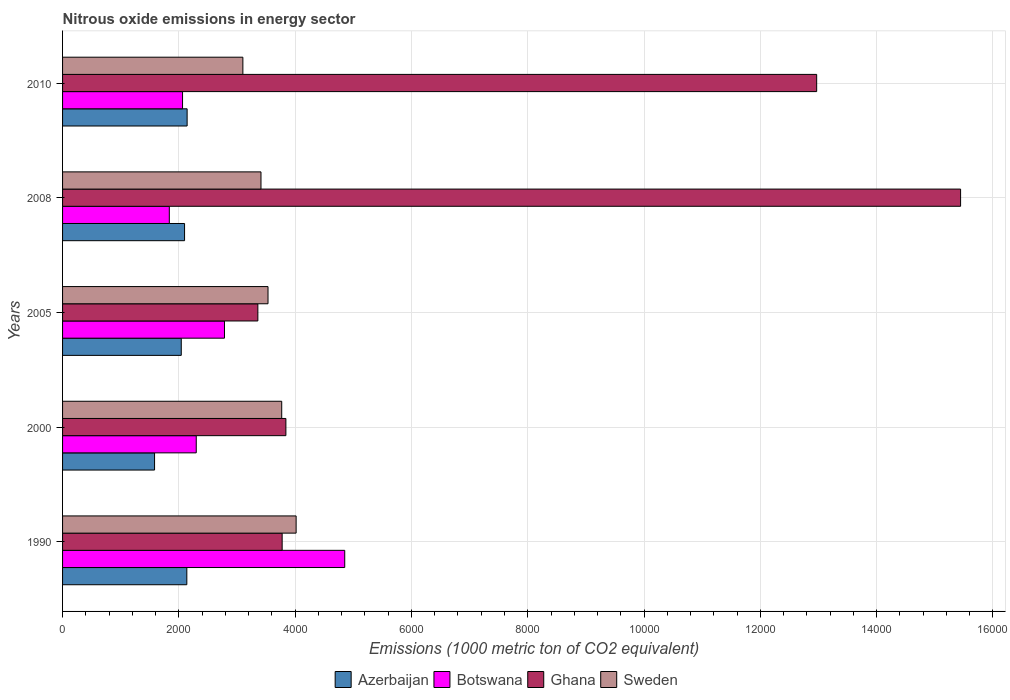How many different coloured bars are there?
Offer a very short reply. 4. Are the number of bars on each tick of the Y-axis equal?
Provide a short and direct response. Yes. How many bars are there on the 5th tick from the top?
Give a very brief answer. 4. How many bars are there on the 2nd tick from the bottom?
Your answer should be compact. 4. In how many cases, is the number of bars for a given year not equal to the number of legend labels?
Keep it short and to the point. 0. What is the amount of nitrous oxide emitted in Sweden in 2005?
Offer a terse response. 3533.4. Across all years, what is the maximum amount of nitrous oxide emitted in Ghana?
Keep it short and to the point. 1.54e+04. Across all years, what is the minimum amount of nitrous oxide emitted in Botswana?
Provide a succinct answer. 1835.8. In which year was the amount of nitrous oxide emitted in Azerbaijan maximum?
Provide a succinct answer. 2010. What is the total amount of nitrous oxide emitted in Azerbaijan in the graph?
Ensure brevity in your answer.  1.00e+04. What is the difference between the amount of nitrous oxide emitted in Ghana in 1990 and that in 2010?
Offer a very short reply. -9192.5. What is the difference between the amount of nitrous oxide emitted in Sweden in 1990 and the amount of nitrous oxide emitted in Botswana in 2008?
Your answer should be compact. 2180.9. What is the average amount of nitrous oxide emitted in Ghana per year?
Make the answer very short. 7877.78. In the year 1990, what is the difference between the amount of nitrous oxide emitted in Sweden and amount of nitrous oxide emitted in Azerbaijan?
Provide a short and direct response. 1879.6. What is the ratio of the amount of nitrous oxide emitted in Botswana in 2000 to that in 2008?
Provide a short and direct response. 1.25. What is the difference between the highest and the lowest amount of nitrous oxide emitted in Sweden?
Keep it short and to the point. 915.7. In how many years, is the amount of nitrous oxide emitted in Sweden greater than the average amount of nitrous oxide emitted in Sweden taken over all years?
Keep it short and to the point. 2. Is the sum of the amount of nitrous oxide emitted in Ghana in 1990 and 2005 greater than the maximum amount of nitrous oxide emitted in Botswana across all years?
Provide a succinct answer. Yes. Is it the case that in every year, the sum of the amount of nitrous oxide emitted in Azerbaijan and amount of nitrous oxide emitted in Botswana is greater than the sum of amount of nitrous oxide emitted in Sweden and amount of nitrous oxide emitted in Ghana?
Make the answer very short. Yes. What does the 1st bar from the top in 2000 represents?
Provide a short and direct response. Sweden. What does the 2nd bar from the bottom in 2005 represents?
Give a very brief answer. Botswana. Is it the case that in every year, the sum of the amount of nitrous oxide emitted in Ghana and amount of nitrous oxide emitted in Sweden is greater than the amount of nitrous oxide emitted in Azerbaijan?
Provide a succinct answer. Yes. How many bars are there?
Make the answer very short. 20. Are all the bars in the graph horizontal?
Offer a terse response. Yes. How many years are there in the graph?
Make the answer very short. 5. Are the values on the major ticks of X-axis written in scientific E-notation?
Offer a very short reply. No. Does the graph contain any zero values?
Provide a succinct answer. No. How are the legend labels stacked?
Offer a very short reply. Horizontal. What is the title of the graph?
Ensure brevity in your answer.  Nitrous oxide emissions in energy sector. What is the label or title of the X-axis?
Offer a very short reply. Emissions (1000 metric ton of CO2 equivalent). What is the Emissions (1000 metric ton of CO2 equivalent) of Azerbaijan in 1990?
Ensure brevity in your answer.  2137.1. What is the Emissions (1000 metric ton of CO2 equivalent) in Botswana in 1990?
Provide a short and direct response. 4852.7. What is the Emissions (1000 metric ton of CO2 equivalent) of Ghana in 1990?
Your answer should be compact. 3776.4. What is the Emissions (1000 metric ton of CO2 equivalent) of Sweden in 1990?
Your response must be concise. 4016.7. What is the Emissions (1000 metric ton of CO2 equivalent) of Azerbaijan in 2000?
Your answer should be compact. 1582.1. What is the Emissions (1000 metric ton of CO2 equivalent) of Botswana in 2000?
Provide a succinct answer. 2299. What is the Emissions (1000 metric ton of CO2 equivalent) of Ghana in 2000?
Keep it short and to the point. 3840.8. What is the Emissions (1000 metric ton of CO2 equivalent) of Sweden in 2000?
Keep it short and to the point. 3769. What is the Emissions (1000 metric ton of CO2 equivalent) in Azerbaijan in 2005?
Your response must be concise. 2041.5. What is the Emissions (1000 metric ton of CO2 equivalent) of Botswana in 2005?
Give a very brief answer. 2784.6. What is the Emissions (1000 metric ton of CO2 equivalent) in Ghana in 2005?
Keep it short and to the point. 3358.7. What is the Emissions (1000 metric ton of CO2 equivalent) of Sweden in 2005?
Ensure brevity in your answer.  3533.4. What is the Emissions (1000 metric ton of CO2 equivalent) in Azerbaijan in 2008?
Your response must be concise. 2098. What is the Emissions (1000 metric ton of CO2 equivalent) of Botswana in 2008?
Ensure brevity in your answer.  1835.8. What is the Emissions (1000 metric ton of CO2 equivalent) of Ghana in 2008?
Provide a succinct answer. 1.54e+04. What is the Emissions (1000 metric ton of CO2 equivalent) in Sweden in 2008?
Ensure brevity in your answer.  3412.4. What is the Emissions (1000 metric ton of CO2 equivalent) in Azerbaijan in 2010?
Your answer should be compact. 2142.1. What is the Emissions (1000 metric ton of CO2 equivalent) of Botswana in 2010?
Your answer should be very brief. 2063.5. What is the Emissions (1000 metric ton of CO2 equivalent) of Ghana in 2010?
Provide a short and direct response. 1.30e+04. What is the Emissions (1000 metric ton of CO2 equivalent) in Sweden in 2010?
Your response must be concise. 3101. Across all years, what is the maximum Emissions (1000 metric ton of CO2 equivalent) of Azerbaijan?
Make the answer very short. 2142.1. Across all years, what is the maximum Emissions (1000 metric ton of CO2 equivalent) in Botswana?
Your answer should be compact. 4852.7. Across all years, what is the maximum Emissions (1000 metric ton of CO2 equivalent) of Ghana?
Offer a very short reply. 1.54e+04. Across all years, what is the maximum Emissions (1000 metric ton of CO2 equivalent) in Sweden?
Keep it short and to the point. 4016.7. Across all years, what is the minimum Emissions (1000 metric ton of CO2 equivalent) of Azerbaijan?
Make the answer very short. 1582.1. Across all years, what is the minimum Emissions (1000 metric ton of CO2 equivalent) of Botswana?
Your response must be concise. 1835.8. Across all years, what is the minimum Emissions (1000 metric ton of CO2 equivalent) of Ghana?
Offer a very short reply. 3358.7. Across all years, what is the minimum Emissions (1000 metric ton of CO2 equivalent) in Sweden?
Offer a terse response. 3101. What is the total Emissions (1000 metric ton of CO2 equivalent) in Azerbaijan in the graph?
Your answer should be compact. 1.00e+04. What is the total Emissions (1000 metric ton of CO2 equivalent) of Botswana in the graph?
Provide a succinct answer. 1.38e+04. What is the total Emissions (1000 metric ton of CO2 equivalent) of Ghana in the graph?
Your answer should be very brief. 3.94e+04. What is the total Emissions (1000 metric ton of CO2 equivalent) in Sweden in the graph?
Provide a succinct answer. 1.78e+04. What is the difference between the Emissions (1000 metric ton of CO2 equivalent) in Azerbaijan in 1990 and that in 2000?
Make the answer very short. 555. What is the difference between the Emissions (1000 metric ton of CO2 equivalent) of Botswana in 1990 and that in 2000?
Provide a succinct answer. 2553.7. What is the difference between the Emissions (1000 metric ton of CO2 equivalent) of Ghana in 1990 and that in 2000?
Your answer should be compact. -64.4. What is the difference between the Emissions (1000 metric ton of CO2 equivalent) of Sweden in 1990 and that in 2000?
Provide a succinct answer. 247.7. What is the difference between the Emissions (1000 metric ton of CO2 equivalent) of Azerbaijan in 1990 and that in 2005?
Offer a terse response. 95.6. What is the difference between the Emissions (1000 metric ton of CO2 equivalent) in Botswana in 1990 and that in 2005?
Your response must be concise. 2068.1. What is the difference between the Emissions (1000 metric ton of CO2 equivalent) in Ghana in 1990 and that in 2005?
Keep it short and to the point. 417.7. What is the difference between the Emissions (1000 metric ton of CO2 equivalent) in Sweden in 1990 and that in 2005?
Offer a very short reply. 483.3. What is the difference between the Emissions (1000 metric ton of CO2 equivalent) of Azerbaijan in 1990 and that in 2008?
Your answer should be very brief. 39.1. What is the difference between the Emissions (1000 metric ton of CO2 equivalent) in Botswana in 1990 and that in 2008?
Your answer should be very brief. 3016.9. What is the difference between the Emissions (1000 metric ton of CO2 equivalent) of Ghana in 1990 and that in 2008?
Provide a succinct answer. -1.17e+04. What is the difference between the Emissions (1000 metric ton of CO2 equivalent) in Sweden in 1990 and that in 2008?
Your answer should be compact. 604.3. What is the difference between the Emissions (1000 metric ton of CO2 equivalent) of Azerbaijan in 1990 and that in 2010?
Ensure brevity in your answer.  -5. What is the difference between the Emissions (1000 metric ton of CO2 equivalent) of Botswana in 1990 and that in 2010?
Provide a succinct answer. 2789.2. What is the difference between the Emissions (1000 metric ton of CO2 equivalent) of Ghana in 1990 and that in 2010?
Provide a succinct answer. -9192.5. What is the difference between the Emissions (1000 metric ton of CO2 equivalent) of Sweden in 1990 and that in 2010?
Ensure brevity in your answer.  915.7. What is the difference between the Emissions (1000 metric ton of CO2 equivalent) in Azerbaijan in 2000 and that in 2005?
Ensure brevity in your answer.  -459.4. What is the difference between the Emissions (1000 metric ton of CO2 equivalent) in Botswana in 2000 and that in 2005?
Your answer should be compact. -485.6. What is the difference between the Emissions (1000 metric ton of CO2 equivalent) in Ghana in 2000 and that in 2005?
Offer a very short reply. 482.1. What is the difference between the Emissions (1000 metric ton of CO2 equivalent) in Sweden in 2000 and that in 2005?
Your answer should be compact. 235.6. What is the difference between the Emissions (1000 metric ton of CO2 equivalent) of Azerbaijan in 2000 and that in 2008?
Make the answer very short. -515.9. What is the difference between the Emissions (1000 metric ton of CO2 equivalent) of Botswana in 2000 and that in 2008?
Ensure brevity in your answer.  463.2. What is the difference between the Emissions (1000 metric ton of CO2 equivalent) in Ghana in 2000 and that in 2008?
Your answer should be very brief. -1.16e+04. What is the difference between the Emissions (1000 metric ton of CO2 equivalent) of Sweden in 2000 and that in 2008?
Give a very brief answer. 356.6. What is the difference between the Emissions (1000 metric ton of CO2 equivalent) in Azerbaijan in 2000 and that in 2010?
Offer a very short reply. -560. What is the difference between the Emissions (1000 metric ton of CO2 equivalent) in Botswana in 2000 and that in 2010?
Ensure brevity in your answer.  235.5. What is the difference between the Emissions (1000 metric ton of CO2 equivalent) in Ghana in 2000 and that in 2010?
Provide a succinct answer. -9128.1. What is the difference between the Emissions (1000 metric ton of CO2 equivalent) in Sweden in 2000 and that in 2010?
Your response must be concise. 668. What is the difference between the Emissions (1000 metric ton of CO2 equivalent) in Azerbaijan in 2005 and that in 2008?
Provide a short and direct response. -56.5. What is the difference between the Emissions (1000 metric ton of CO2 equivalent) of Botswana in 2005 and that in 2008?
Provide a succinct answer. 948.8. What is the difference between the Emissions (1000 metric ton of CO2 equivalent) of Ghana in 2005 and that in 2008?
Give a very brief answer. -1.21e+04. What is the difference between the Emissions (1000 metric ton of CO2 equivalent) in Sweden in 2005 and that in 2008?
Ensure brevity in your answer.  121. What is the difference between the Emissions (1000 metric ton of CO2 equivalent) in Azerbaijan in 2005 and that in 2010?
Your answer should be very brief. -100.6. What is the difference between the Emissions (1000 metric ton of CO2 equivalent) in Botswana in 2005 and that in 2010?
Offer a terse response. 721.1. What is the difference between the Emissions (1000 metric ton of CO2 equivalent) in Ghana in 2005 and that in 2010?
Provide a succinct answer. -9610.2. What is the difference between the Emissions (1000 metric ton of CO2 equivalent) of Sweden in 2005 and that in 2010?
Your response must be concise. 432.4. What is the difference between the Emissions (1000 metric ton of CO2 equivalent) in Azerbaijan in 2008 and that in 2010?
Keep it short and to the point. -44.1. What is the difference between the Emissions (1000 metric ton of CO2 equivalent) of Botswana in 2008 and that in 2010?
Your response must be concise. -227.7. What is the difference between the Emissions (1000 metric ton of CO2 equivalent) in Ghana in 2008 and that in 2010?
Give a very brief answer. 2475.2. What is the difference between the Emissions (1000 metric ton of CO2 equivalent) of Sweden in 2008 and that in 2010?
Make the answer very short. 311.4. What is the difference between the Emissions (1000 metric ton of CO2 equivalent) in Azerbaijan in 1990 and the Emissions (1000 metric ton of CO2 equivalent) in Botswana in 2000?
Your answer should be very brief. -161.9. What is the difference between the Emissions (1000 metric ton of CO2 equivalent) of Azerbaijan in 1990 and the Emissions (1000 metric ton of CO2 equivalent) of Ghana in 2000?
Your response must be concise. -1703.7. What is the difference between the Emissions (1000 metric ton of CO2 equivalent) of Azerbaijan in 1990 and the Emissions (1000 metric ton of CO2 equivalent) of Sweden in 2000?
Offer a very short reply. -1631.9. What is the difference between the Emissions (1000 metric ton of CO2 equivalent) in Botswana in 1990 and the Emissions (1000 metric ton of CO2 equivalent) in Ghana in 2000?
Your answer should be very brief. 1011.9. What is the difference between the Emissions (1000 metric ton of CO2 equivalent) of Botswana in 1990 and the Emissions (1000 metric ton of CO2 equivalent) of Sweden in 2000?
Give a very brief answer. 1083.7. What is the difference between the Emissions (1000 metric ton of CO2 equivalent) in Ghana in 1990 and the Emissions (1000 metric ton of CO2 equivalent) in Sweden in 2000?
Give a very brief answer. 7.4. What is the difference between the Emissions (1000 metric ton of CO2 equivalent) in Azerbaijan in 1990 and the Emissions (1000 metric ton of CO2 equivalent) in Botswana in 2005?
Offer a very short reply. -647.5. What is the difference between the Emissions (1000 metric ton of CO2 equivalent) in Azerbaijan in 1990 and the Emissions (1000 metric ton of CO2 equivalent) in Ghana in 2005?
Ensure brevity in your answer.  -1221.6. What is the difference between the Emissions (1000 metric ton of CO2 equivalent) in Azerbaijan in 1990 and the Emissions (1000 metric ton of CO2 equivalent) in Sweden in 2005?
Provide a succinct answer. -1396.3. What is the difference between the Emissions (1000 metric ton of CO2 equivalent) of Botswana in 1990 and the Emissions (1000 metric ton of CO2 equivalent) of Ghana in 2005?
Your response must be concise. 1494. What is the difference between the Emissions (1000 metric ton of CO2 equivalent) of Botswana in 1990 and the Emissions (1000 metric ton of CO2 equivalent) of Sweden in 2005?
Your answer should be compact. 1319.3. What is the difference between the Emissions (1000 metric ton of CO2 equivalent) of Ghana in 1990 and the Emissions (1000 metric ton of CO2 equivalent) of Sweden in 2005?
Offer a very short reply. 243. What is the difference between the Emissions (1000 metric ton of CO2 equivalent) in Azerbaijan in 1990 and the Emissions (1000 metric ton of CO2 equivalent) in Botswana in 2008?
Provide a succinct answer. 301.3. What is the difference between the Emissions (1000 metric ton of CO2 equivalent) in Azerbaijan in 1990 and the Emissions (1000 metric ton of CO2 equivalent) in Ghana in 2008?
Provide a succinct answer. -1.33e+04. What is the difference between the Emissions (1000 metric ton of CO2 equivalent) in Azerbaijan in 1990 and the Emissions (1000 metric ton of CO2 equivalent) in Sweden in 2008?
Provide a succinct answer. -1275.3. What is the difference between the Emissions (1000 metric ton of CO2 equivalent) of Botswana in 1990 and the Emissions (1000 metric ton of CO2 equivalent) of Ghana in 2008?
Your answer should be compact. -1.06e+04. What is the difference between the Emissions (1000 metric ton of CO2 equivalent) of Botswana in 1990 and the Emissions (1000 metric ton of CO2 equivalent) of Sweden in 2008?
Give a very brief answer. 1440.3. What is the difference between the Emissions (1000 metric ton of CO2 equivalent) in Ghana in 1990 and the Emissions (1000 metric ton of CO2 equivalent) in Sweden in 2008?
Your answer should be compact. 364. What is the difference between the Emissions (1000 metric ton of CO2 equivalent) in Azerbaijan in 1990 and the Emissions (1000 metric ton of CO2 equivalent) in Botswana in 2010?
Keep it short and to the point. 73.6. What is the difference between the Emissions (1000 metric ton of CO2 equivalent) of Azerbaijan in 1990 and the Emissions (1000 metric ton of CO2 equivalent) of Ghana in 2010?
Offer a terse response. -1.08e+04. What is the difference between the Emissions (1000 metric ton of CO2 equivalent) of Azerbaijan in 1990 and the Emissions (1000 metric ton of CO2 equivalent) of Sweden in 2010?
Offer a very short reply. -963.9. What is the difference between the Emissions (1000 metric ton of CO2 equivalent) in Botswana in 1990 and the Emissions (1000 metric ton of CO2 equivalent) in Ghana in 2010?
Provide a short and direct response. -8116.2. What is the difference between the Emissions (1000 metric ton of CO2 equivalent) of Botswana in 1990 and the Emissions (1000 metric ton of CO2 equivalent) of Sweden in 2010?
Make the answer very short. 1751.7. What is the difference between the Emissions (1000 metric ton of CO2 equivalent) in Ghana in 1990 and the Emissions (1000 metric ton of CO2 equivalent) in Sweden in 2010?
Your answer should be very brief. 675.4. What is the difference between the Emissions (1000 metric ton of CO2 equivalent) in Azerbaijan in 2000 and the Emissions (1000 metric ton of CO2 equivalent) in Botswana in 2005?
Make the answer very short. -1202.5. What is the difference between the Emissions (1000 metric ton of CO2 equivalent) in Azerbaijan in 2000 and the Emissions (1000 metric ton of CO2 equivalent) in Ghana in 2005?
Your response must be concise. -1776.6. What is the difference between the Emissions (1000 metric ton of CO2 equivalent) of Azerbaijan in 2000 and the Emissions (1000 metric ton of CO2 equivalent) of Sweden in 2005?
Your response must be concise. -1951.3. What is the difference between the Emissions (1000 metric ton of CO2 equivalent) in Botswana in 2000 and the Emissions (1000 metric ton of CO2 equivalent) in Ghana in 2005?
Provide a short and direct response. -1059.7. What is the difference between the Emissions (1000 metric ton of CO2 equivalent) in Botswana in 2000 and the Emissions (1000 metric ton of CO2 equivalent) in Sweden in 2005?
Provide a short and direct response. -1234.4. What is the difference between the Emissions (1000 metric ton of CO2 equivalent) in Ghana in 2000 and the Emissions (1000 metric ton of CO2 equivalent) in Sweden in 2005?
Give a very brief answer. 307.4. What is the difference between the Emissions (1000 metric ton of CO2 equivalent) in Azerbaijan in 2000 and the Emissions (1000 metric ton of CO2 equivalent) in Botswana in 2008?
Offer a terse response. -253.7. What is the difference between the Emissions (1000 metric ton of CO2 equivalent) of Azerbaijan in 2000 and the Emissions (1000 metric ton of CO2 equivalent) of Ghana in 2008?
Give a very brief answer. -1.39e+04. What is the difference between the Emissions (1000 metric ton of CO2 equivalent) in Azerbaijan in 2000 and the Emissions (1000 metric ton of CO2 equivalent) in Sweden in 2008?
Keep it short and to the point. -1830.3. What is the difference between the Emissions (1000 metric ton of CO2 equivalent) in Botswana in 2000 and the Emissions (1000 metric ton of CO2 equivalent) in Ghana in 2008?
Your response must be concise. -1.31e+04. What is the difference between the Emissions (1000 metric ton of CO2 equivalent) in Botswana in 2000 and the Emissions (1000 metric ton of CO2 equivalent) in Sweden in 2008?
Offer a very short reply. -1113.4. What is the difference between the Emissions (1000 metric ton of CO2 equivalent) in Ghana in 2000 and the Emissions (1000 metric ton of CO2 equivalent) in Sweden in 2008?
Make the answer very short. 428.4. What is the difference between the Emissions (1000 metric ton of CO2 equivalent) in Azerbaijan in 2000 and the Emissions (1000 metric ton of CO2 equivalent) in Botswana in 2010?
Your answer should be compact. -481.4. What is the difference between the Emissions (1000 metric ton of CO2 equivalent) in Azerbaijan in 2000 and the Emissions (1000 metric ton of CO2 equivalent) in Ghana in 2010?
Offer a terse response. -1.14e+04. What is the difference between the Emissions (1000 metric ton of CO2 equivalent) in Azerbaijan in 2000 and the Emissions (1000 metric ton of CO2 equivalent) in Sweden in 2010?
Ensure brevity in your answer.  -1518.9. What is the difference between the Emissions (1000 metric ton of CO2 equivalent) of Botswana in 2000 and the Emissions (1000 metric ton of CO2 equivalent) of Ghana in 2010?
Provide a succinct answer. -1.07e+04. What is the difference between the Emissions (1000 metric ton of CO2 equivalent) in Botswana in 2000 and the Emissions (1000 metric ton of CO2 equivalent) in Sweden in 2010?
Make the answer very short. -802. What is the difference between the Emissions (1000 metric ton of CO2 equivalent) in Ghana in 2000 and the Emissions (1000 metric ton of CO2 equivalent) in Sweden in 2010?
Offer a terse response. 739.8. What is the difference between the Emissions (1000 metric ton of CO2 equivalent) in Azerbaijan in 2005 and the Emissions (1000 metric ton of CO2 equivalent) in Botswana in 2008?
Give a very brief answer. 205.7. What is the difference between the Emissions (1000 metric ton of CO2 equivalent) of Azerbaijan in 2005 and the Emissions (1000 metric ton of CO2 equivalent) of Ghana in 2008?
Your response must be concise. -1.34e+04. What is the difference between the Emissions (1000 metric ton of CO2 equivalent) in Azerbaijan in 2005 and the Emissions (1000 metric ton of CO2 equivalent) in Sweden in 2008?
Provide a succinct answer. -1370.9. What is the difference between the Emissions (1000 metric ton of CO2 equivalent) of Botswana in 2005 and the Emissions (1000 metric ton of CO2 equivalent) of Ghana in 2008?
Give a very brief answer. -1.27e+04. What is the difference between the Emissions (1000 metric ton of CO2 equivalent) in Botswana in 2005 and the Emissions (1000 metric ton of CO2 equivalent) in Sweden in 2008?
Offer a terse response. -627.8. What is the difference between the Emissions (1000 metric ton of CO2 equivalent) in Ghana in 2005 and the Emissions (1000 metric ton of CO2 equivalent) in Sweden in 2008?
Give a very brief answer. -53.7. What is the difference between the Emissions (1000 metric ton of CO2 equivalent) in Azerbaijan in 2005 and the Emissions (1000 metric ton of CO2 equivalent) in Ghana in 2010?
Your response must be concise. -1.09e+04. What is the difference between the Emissions (1000 metric ton of CO2 equivalent) in Azerbaijan in 2005 and the Emissions (1000 metric ton of CO2 equivalent) in Sweden in 2010?
Your response must be concise. -1059.5. What is the difference between the Emissions (1000 metric ton of CO2 equivalent) in Botswana in 2005 and the Emissions (1000 metric ton of CO2 equivalent) in Ghana in 2010?
Make the answer very short. -1.02e+04. What is the difference between the Emissions (1000 metric ton of CO2 equivalent) of Botswana in 2005 and the Emissions (1000 metric ton of CO2 equivalent) of Sweden in 2010?
Offer a terse response. -316.4. What is the difference between the Emissions (1000 metric ton of CO2 equivalent) in Ghana in 2005 and the Emissions (1000 metric ton of CO2 equivalent) in Sweden in 2010?
Give a very brief answer. 257.7. What is the difference between the Emissions (1000 metric ton of CO2 equivalent) in Azerbaijan in 2008 and the Emissions (1000 metric ton of CO2 equivalent) in Botswana in 2010?
Keep it short and to the point. 34.5. What is the difference between the Emissions (1000 metric ton of CO2 equivalent) in Azerbaijan in 2008 and the Emissions (1000 metric ton of CO2 equivalent) in Ghana in 2010?
Give a very brief answer. -1.09e+04. What is the difference between the Emissions (1000 metric ton of CO2 equivalent) in Azerbaijan in 2008 and the Emissions (1000 metric ton of CO2 equivalent) in Sweden in 2010?
Your response must be concise. -1003. What is the difference between the Emissions (1000 metric ton of CO2 equivalent) of Botswana in 2008 and the Emissions (1000 metric ton of CO2 equivalent) of Ghana in 2010?
Ensure brevity in your answer.  -1.11e+04. What is the difference between the Emissions (1000 metric ton of CO2 equivalent) of Botswana in 2008 and the Emissions (1000 metric ton of CO2 equivalent) of Sweden in 2010?
Provide a short and direct response. -1265.2. What is the difference between the Emissions (1000 metric ton of CO2 equivalent) of Ghana in 2008 and the Emissions (1000 metric ton of CO2 equivalent) of Sweden in 2010?
Keep it short and to the point. 1.23e+04. What is the average Emissions (1000 metric ton of CO2 equivalent) in Azerbaijan per year?
Make the answer very short. 2000.16. What is the average Emissions (1000 metric ton of CO2 equivalent) in Botswana per year?
Your answer should be very brief. 2767.12. What is the average Emissions (1000 metric ton of CO2 equivalent) of Ghana per year?
Keep it short and to the point. 7877.78. What is the average Emissions (1000 metric ton of CO2 equivalent) of Sweden per year?
Provide a short and direct response. 3566.5. In the year 1990, what is the difference between the Emissions (1000 metric ton of CO2 equivalent) in Azerbaijan and Emissions (1000 metric ton of CO2 equivalent) in Botswana?
Offer a very short reply. -2715.6. In the year 1990, what is the difference between the Emissions (1000 metric ton of CO2 equivalent) of Azerbaijan and Emissions (1000 metric ton of CO2 equivalent) of Ghana?
Provide a succinct answer. -1639.3. In the year 1990, what is the difference between the Emissions (1000 metric ton of CO2 equivalent) of Azerbaijan and Emissions (1000 metric ton of CO2 equivalent) of Sweden?
Give a very brief answer. -1879.6. In the year 1990, what is the difference between the Emissions (1000 metric ton of CO2 equivalent) of Botswana and Emissions (1000 metric ton of CO2 equivalent) of Ghana?
Keep it short and to the point. 1076.3. In the year 1990, what is the difference between the Emissions (1000 metric ton of CO2 equivalent) of Botswana and Emissions (1000 metric ton of CO2 equivalent) of Sweden?
Offer a terse response. 836. In the year 1990, what is the difference between the Emissions (1000 metric ton of CO2 equivalent) of Ghana and Emissions (1000 metric ton of CO2 equivalent) of Sweden?
Your response must be concise. -240.3. In the year 2000, what is the difference between the Emissions (1000 metric ton of CO2 equivalent) in Azerbaijan and Emissions (1000 metric ton of CO2 equivalent) in Botswana?
Offer a terse response. -716.9. In the year 2000, what is the difference between the Emissions (1000 metric ton of CO2 equivalent) in Azerbaijan and Emissions (1000 metric ton of CO2 equivalent) in Ghana?
Keep it short and to the point. -2258.7. In the year 2000, what is the difference between the Emissions (1000 metric ton of CO2 equivalent) in Azerbaijan and Emissions (1000 metric ton of CO2 equivalent) in Sweden?
Your response must be concise. -2186.9. In the year 2000, what is the difference between the Emissions (1000 metric ton of CO2 equivalent) in Botswana and Emissions (1000 metric ton of CO2 equivalent) in Ghana?
Ensure brevity in your answer.  -1541.8. In the year 2000, what is the difference between the Emissions (1000 metric ton of CO2 equivalent) in Botswana and Emissions (1000 metric ton of CO2 equivalent) in Sweden?
Provide a succinct answer. -1470. In the year 2000, what is the difference between the Emissions (1000 metric ton of CO2 equivalent) in Ghana and Emissions (1000 metric ton of CO2 equivalent) in Sweden?
Your answer should be very brief. 71.8. In the year 2005, what is the difference between the Emissions (1000 metric ton of CO2 equivalent) in Azerbaijan and Emissions (1000 metric ton of CO2 equivalent) in Botswana?
Make the answer very short. -743.1. In the year 2005, what is the difference between the Emissions (1000 metric ton of CO2 equivalent) in Azerbaijan and Emissions (1000 metric ton of CO2 equivalent) in Ghana?
Ensure brevity in your answer.  -1317.2. In the year 2005, what is the difference between the Emissions (1000 metric ton of CO2 equivalent) in Azerbaijan and Emissions (1000 metric ton of CO2 equivalent) in Sweden?
Your answer should be compact. -1491.9. In the year 2005, what is the difference between the Emissions (1000 metric ton of CO2 equivalent) of Botswana and Emissions (1000 metric ton of CO2 equivalent) of Ghana?
Your answer should be very brief. -574.1. In the year 2005, what is the difference between the Emissions (1000 metric ton of CO2 equivalent) in Botswana and Emissions (1000 metric ton of CO2 equivalent) in Sweden?
Offer a terse response. -748.8. In the year 2005, what is the difference between the Emissions (1000 metric ton of CO2 equivalent) of Ghana and Emissions (1000 metric ton of CO2 equivalent) of Sweden?
Make the answer very short. -174.7. In the year 2008, what is the difference between the Emissions (1000 metric ton of CO2 equivalent) in Azerbaijan and Emissions (1000 metric ton of CO2 equivalent) in Botswana?
Offer a terse response. 262.2. In the year 2008, what is the difference between the Emissions (1000 metric ton of CO2 equivalent) of Azerbaijan and Emissions (1000 metric ton of CO2 equivalent) of Ghana?
Ensure brevity in your answer.  -1.33e+04. In the year 2008, what is the difference between the Emissions (1000 metric ton of CO2 equivalent) of Azerbaijan and Emissions (1000 metric ton of CO2 equivalent) of Sweden?
Make the answer very short. -1314.4. In the year 2008, what is the difference between the Emissions (1000 metric ton of CO2 equivalent) in Botswana and Emissions (1000 metric ton of CO2 equivalent) in Ghana?
Ensure brevity in your answer.  -1.36e+04. In the year 2008, what is the difference between the Emissions (1000 metric ton of CO2 equivalent) of Botswana and Emissions (1000 metric ton of CO2 equivalent) of Sweden?
Keep it short and to the point. -1576.6. In the year 2008, what is the difference between the Emissions (1000 metric ton of CO2 equivalent) of Ghana and Emissions (1000 metric ton of CO2 equivalent) of Sweden?
Provide a short and direct response. 1.20e+04. In the year 2010, what is the difference between the Emissions (1000 metric ton of CO2 equivalent) in Azerbaijan and Emissions (1000 metric ton of CO2 equivalent) in Botswana?
Keep it short and to the point. 78.6. In the year 2010, what is the difference between the Emissions (1000 metric ton of CO2 equivalent) in Azerbaijan and Emissions (1000 metric ton of CO2 equivalent) in Ghana?
Make the answer very short. -1.08e+04. In the year 2010, what is the difference between the Emissions (1000 metric ton of CO2 equivalent) in Azerbaijan and Emissions (1000 metric ton of CO2 equivalent) in Sweden?
Give a very brief answer. -958.9. In the year 2010, what is the difference between the Emissions (1000 metric ton of CO2 equivalent) in Botswana and Emissions (1000 metric ton of CO2 equivalent) in Ghana?
Your response must be concise. -1.09e+04. In the year 2010, what is the difference between the Emissions (1000 metric ton of CO2 equivalent) of Botswana and Emissions (1000 metric ton of CO2 equivalent) of Sweden?
Offer a terse response. -1037.5. In the year 2010, what is the difference between the Emissions (1000 metric ton of CO2 equivalent) of Ghana and Emissions (1000 metric ton of CO2 equivalent) of Sweden?
Offer a very short reply. 9867.9. What is the ratio of the Emissions (1000 metric ton of CO2 equivalent) of Azerbaijan in 1990 to that in 2000?
Provide a succinct answer. 1.35. What is the ratio of the Emissions (1000 metric ton of CO2 equivalent) in Botswana in 1990 to that in 2000?
Keep it short and to the point. 2.11. What is the ratio of the Emissions (1000 metric ton of CO2 equivalent) of Ghana in 1990 to that in 2000?
Your response must be concise. 0.98. What is the ratio of the Emissions (1000 metric ton of CO2 equivalent) of Sweden in 1990 to that in 2000?
Your answer should be compact. 1.07. What is the ratio of the Emissions (1000 metric ton of CO2 equivalent) in Azerbaijan in 1990 to that in 2005?
Ensure brevity in your answer.  1.05. What is the ratio of the Emissions (1000 metric ton of CO2 equivalent) in Botswana in 1990 to that in 2005?
Give a very brief answer. 1.74. What is the ratio of the Emissions (1000 metric ton of CO2 equivalent) in Ghana in 1990 to that in 2005?
Your answer should be compact. 1.12. What is the ratio of the Emissions (1000 metric ton of CO2 equivalent) of Sweden in 1990 to that in 2005?
Provide a short and direct response. 1.14. What is the ratio of the Emissions (1000 metric ton of CO2 equivalent) in Azerbaijan in 1990 to that in 2008?
Provide a short and direct response. 1.02. What is the ratio of the Emissions (1000 metric ton of CO2 equivalent) of Botswana in 1990 to that in 2008?
Your response must be concise. 2.64. What is the ratio of the Emissions (1000 metric ton of CO2 equivalent) in Ghana in 1990 to that in 2008?
Give a very brief answer. 0.24. What is the ratio of the Emissions (1000 metric ton of CO2 equivalent) of Sweden in 1990 to that in 2008?
Make the answer very short. 1.18. What is the ratio of the Emissions (1000 metric ton of CO2 equivalent) in Botswana in 1990 to that in 2010?
Keep it short and to the point. 2.35. What is the ratio of the Emissions (1000 metric ton of CO2 equivalent) of Ghana in 1990 to that in 2010?
Offer a terse response. 0.29. What is the ratio of the Emissions (1000 metric ton of CO2 equivalent) of Sweden in 1990 to that in 2010?
Your answer should be very brief. 1.3. What is the ratio of the Emissions (1000 metric ton of CO2 equivalent) of Azerbaijan in 2000 to that in 2005?
Your answer should be compact. 0.78. What is the ratio of the Emissions (1000 metric ton of CO2 equivalent) of Botswana in 2000 to that in 2005?
Offer a terse response. 0.83. What is the ratio of the Emissions (1000 metric ton of CO2 equivalent) in Ghana in 2000 to that in 2005?
Give a very brief answer. 1.14. What is the ratio of the Emissions (1000 metric ton of CO2 equivalent) in Sweden in 2000 to that in 2005?
Your answer should be compact. 1.07. What is the ratio of the Emissions (1000 metric ton of CO2 equivalent) of Azerbaijan in 2000 to that in 2008?
Provide a succinct answer. 0.75. What is the ratio of the Emissions (1000 metric ton of CO2 equivalent) of Botswana in 2000 to that in 2008?
Make the answer very short. 1.25. What is the ratio of the Emissions (1000 metric ton of CO2 equivalent) in Ghana in 2000 to that in 2008?
Provide a short and direct response. 0.25. What is the ratio of the Emissions (1000 metric ton of CO2 equivalent) in Sweden in 2000 to that in 2008?
Keep it short and to the point. 1.1. What is the ratio of the Emissions (1000 metric ton of CO2 equivalent) in Azerbaijan in 2000 to that in 2010?
Provide a succinct answer. 0.74. What is the ratio of the Emissions (1000 metric ton of CO2 equivalent) in Botswana in 2000 to that in 2010?
Your answer should be compact. 1.11. What is the ratio of the Emissions (1000 metric ton of CO2 equivalent) in Ghana in 2000 to that in 2010?
Offer a very short reply. 0.3. What is the ratio of the Emissions (1000 metric ton of CO2 equivalent) of Sweden in 2000 to that in 2010?
Provide a short and direct response. 1.22. What is the ratio of the Emissions (1000 metric ton of CO2 equivalent) of Azerbaijan in 2005 to that in 2008?
Ensure brevity in your answer.  0.97. What is the ratio of the Emissions (1000 metric ton of CO2 equivalent) of Botswana in 2005 to that in 2008?
Your answer should be very brief. 1.52. What is the ratio of the Emissions (1000 metric ton of CO2 equivalent) in Ghana in 2005 to that in 2008?
Your answer should be compact. 0.22. What is the ratio of the Emissions (1000 metric ton of CO2 equivalent) of Sweden in 2005 to that in 2008?
Your answer should be compact. 1.04. What is the ratio of the Emissions (1000 metric ton of CO2 equivalent) of Azerbaijan in 2005 to that in 2010?
Offer a very short reply. 0.95. What is the ratio of the Emissions (1000 metric ton of CO2 equivalent) of Botswana in 2005 to that in 2010?
Ensure brevity in your answer.  1.35. What is the ratio of the Emissions (1000 metric ton of CO2 equivalent) in Ghana in 2005 to that in 2010?
Offer a terse response. 0.26. What is the ratio of the Emissions (1000 metric ton of CO2 equivalent) of Sweden in 2005 to that in 2010?
Keep it short and to the point. 1.14. What is the ratio of the Emissions (1000 metric ton of CO2 equivalent) of Azerbaijan in 2008 to that in 2010?
Your answer should be very brief. 0.98. What is the ratio of the Emissions (1000 metric ton of CO2 equivalent) of Botswana in 2008 to that in 2010?
Your answer should be compact. 0.89. What is the ratio of the Emissions (1000 metric ton of CO2 equivalent) in Ghana in 2008 to that in 2010?
Make the answer very short. 1.19. What is the ratio of the Emissions (1000 metric ton of CO2 equivalent) of Sweden in 2008 to that in 2010?
Keep it short and to the point. 1.1. What is the difference between the highest and the second highest Emissions (1000 metric ton of CO2 equivalent) in Botswana?
Your answer should be very brief. 2068.1. What is the difference between the highest and the second highest Emissions (1000 metric ton of CO2 equivalent) of Ghana?
Keep it short and to the point. 2475.2. What is the difference between the highest and the second highest Emissions (1000 metric ton of CO2 equivalent) of Sweden?
Make the answer very short. 247.7. What is the difference between the highest and the lowest Emissions (1000 metric ton of CO2 equivalent) of Azerbaijan?
Give a very brief answer. 560. What is the difference between the highest and the lowest Emissions (1000 metric ton of CO2 equivalent) of Botswana?
Make the answer very short. 3016.9. What is the difference between the highest and the lowest Emissions (1000 metric ton of CO2 equivalent) of Ghana?
Offer a very short reply. 1.21e+04. What is the difference between the highest and the lowest Emissions (1000 metric ton of CO2 equivalent) in Sweden?
Give a very brief answer. 915.7. 